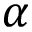Convert formula to latex. <formula><loc_0><loc_0><loc_500><loc_500>\alpha</formula> 